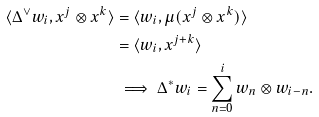<formula> <loc_0><loc_0><loc_500><loc_500>\langle \Delta ^ { \vee } w _ { i } , x ^ { j } \otimes x ^ { k } \rangle & = \langle w _ { i } , \mu ( x ^ { j } \otimes x ^ { k } ) \rangle \\ & = \langle w _ { i } , x ^ { j + k } \rangle \\ & \implies \Delta ^ { * } w _ { i } = \sum _ { n = 0 } ^ { i } w _ { n } \otimes w _ { i - n } .</formula> 